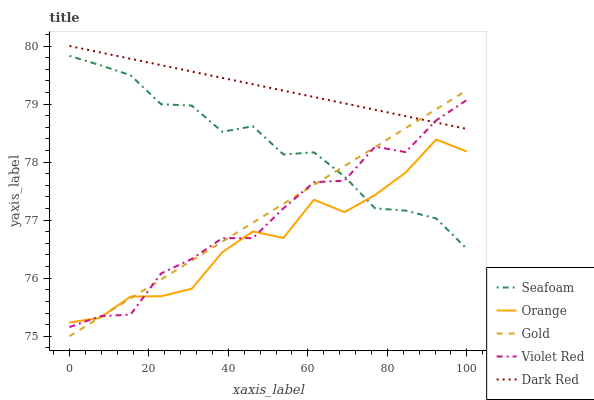Does Violet Red have the minimum area under the curve?
Answer yes or no. No. Does Violet Red have the maximum area under the curve?
Answer yes or no. No. Is Dark Red the smoothest?
Answer yes or no. No. Is Dark Red the roughest?
Answer yes or no. No. Does Violet Red have the lowest value?
Answer yes or no. No. Does Violet Red have the highest value?
Answer yes or no. No. Is Orange less than Dark Red?
Answer yes or no. Yes. Is Dark Red greater than Seafoam?
Answer yes or no. Yes. Does Orange intersect Dark Red?
Answer yes or no. No. 